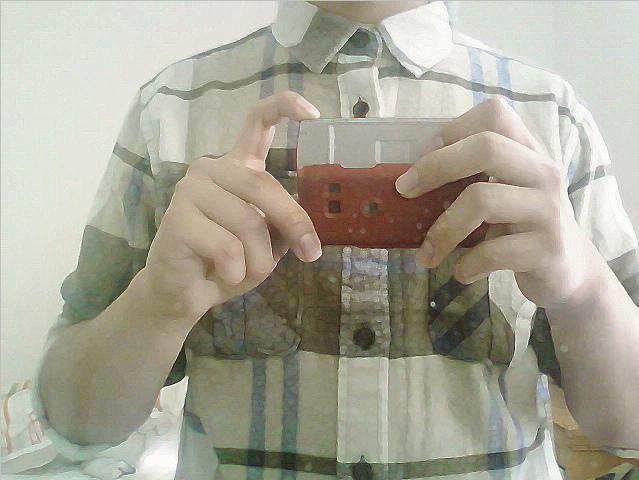How many elephants have trunk?
Give a very brief answer. 0. 